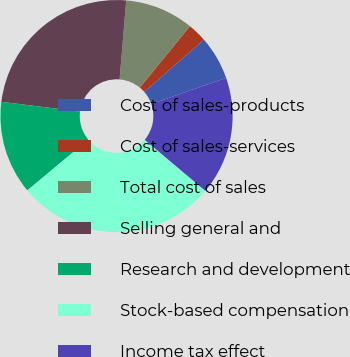<chart> <loc_0><loc_0><loc_500><loc_500><pie_chart><fcel>Cost of sales-products<fcel>Cost of sales-services<fcel>Total cost of sales<fcel>Selling general and<fcel>Research and development<fcel>Stock-based compensation<fcel>Income tax effect<nl><fcel>6.11%<fcel>2.66%<fcel>9.57%<fcel>24.36%<fcel>13.02%<fcel>27.81%<fcel>16.47%<nl></chart> 